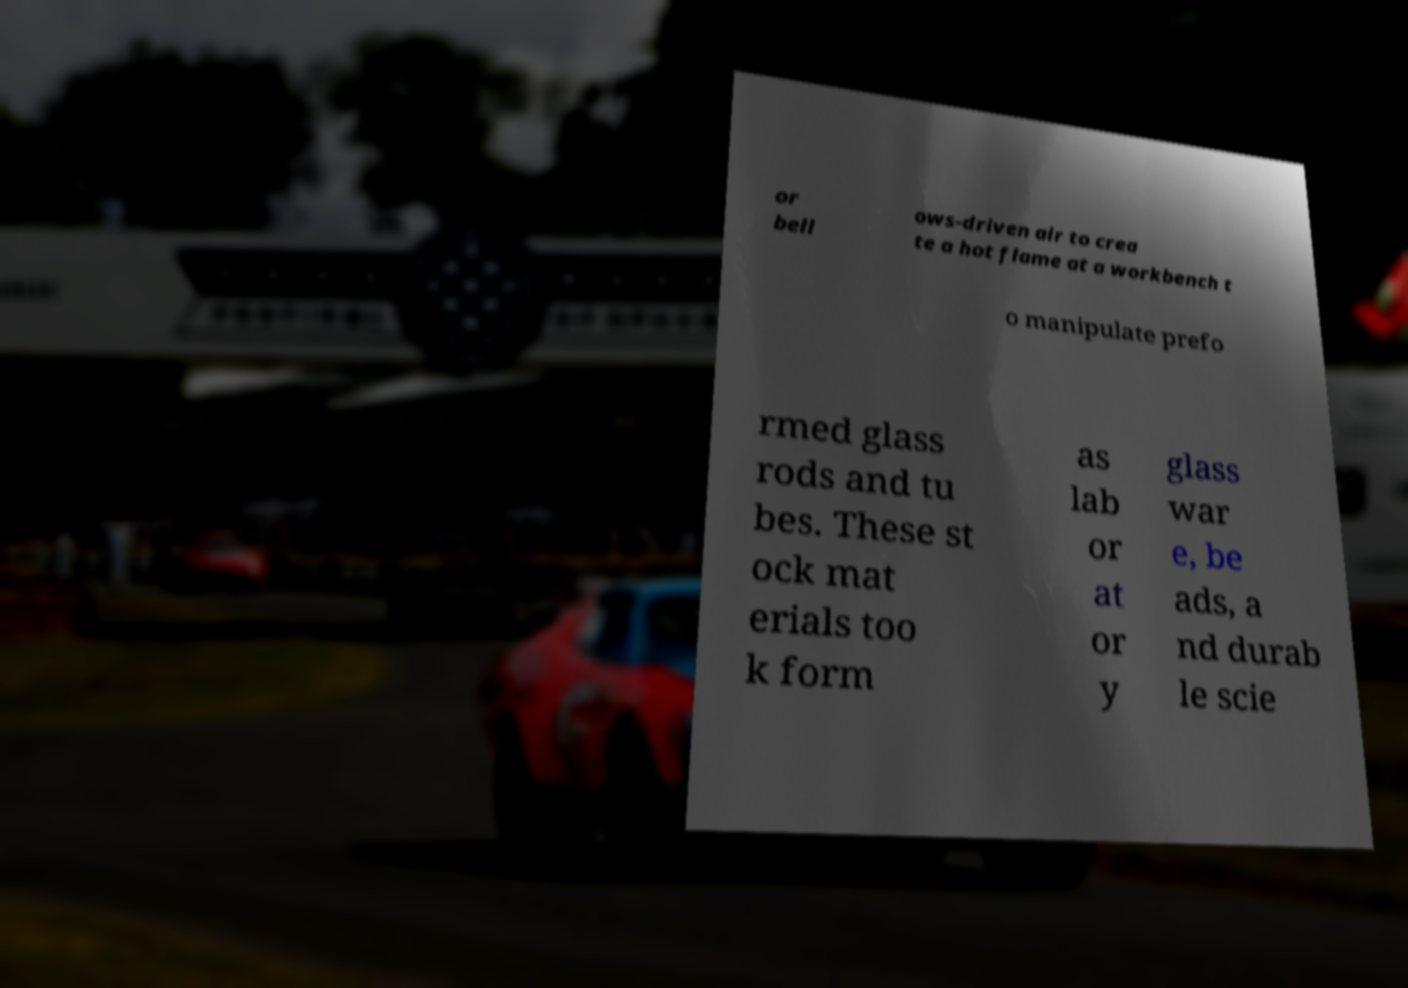Could you assist in decoding the text presented in this image and type it out clearly? or bell ows-driven air to crea te a hot flame at a workbench t o manipulate prefo rmed glass rods and tu bes. These st ock mat erials too k form as lab or at or y glass war e, be ads, a nd durab le scie 